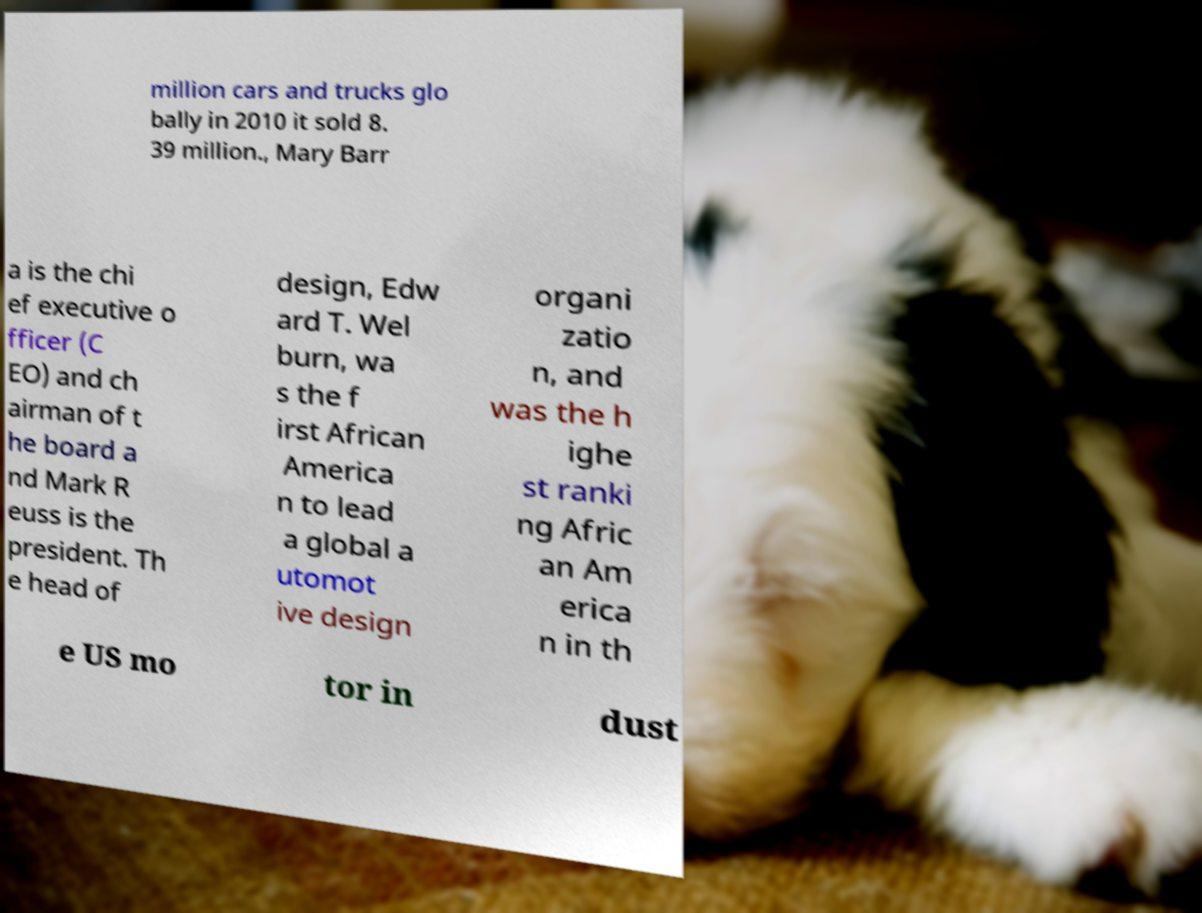What messages or text are displayed in this image? I need them in a readable, typed format. million cars and trucks glo bally in 2010 it sold 8. 39 million., Mary Barr a is the chi ef executive o fficer (C EO) and ch airman of t he board a nd Mark R euss is the president. Th e head of design, Edw ard T. Wel burn, wa s the f irst African America n to lead a global a utomot ive design organi zatio n, and was the h ighe st ranki ng Afric an Am erica n in th e US mo tor in dust 